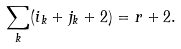Convert formula to latex. <formula><loc_0><loc_0><loc_500><loc_500>\sum _ { k } ( i _ { k } + j _ { k } + 2 ) = r + 2 .</formula> 